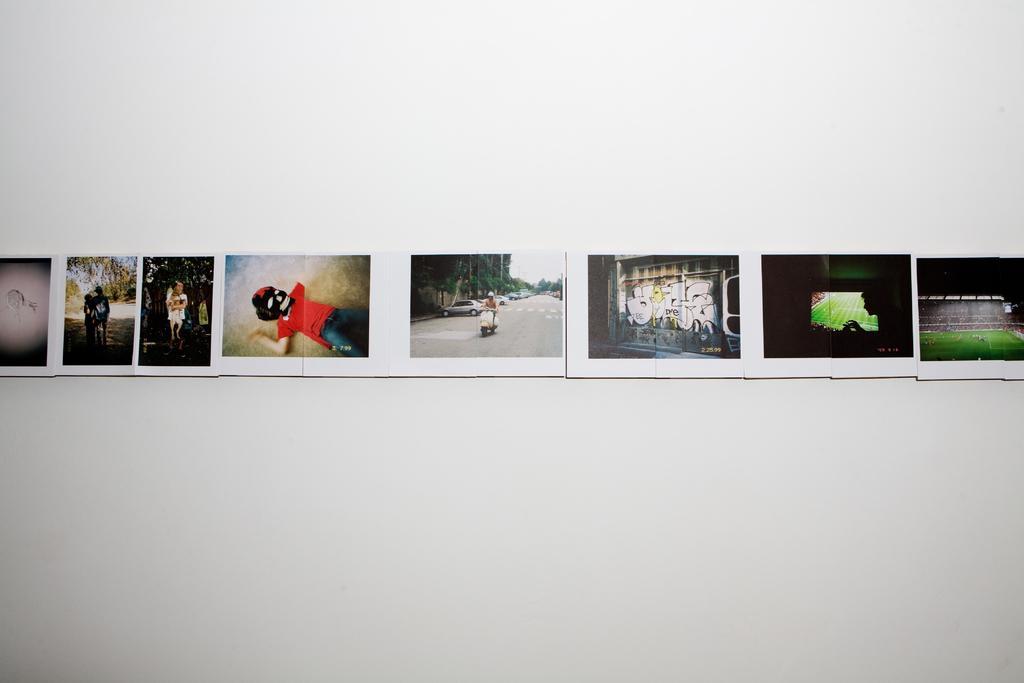Describe this image in one or two sentences. In this image image there are many photographs on the wall. Here a person is riding a scooter on the road, beside the road there are many cars and trees. Here there is a person on the ground wearing a mask. In this picture there is a person. On the right one there is a picture of a ground. The wall is white in color. 